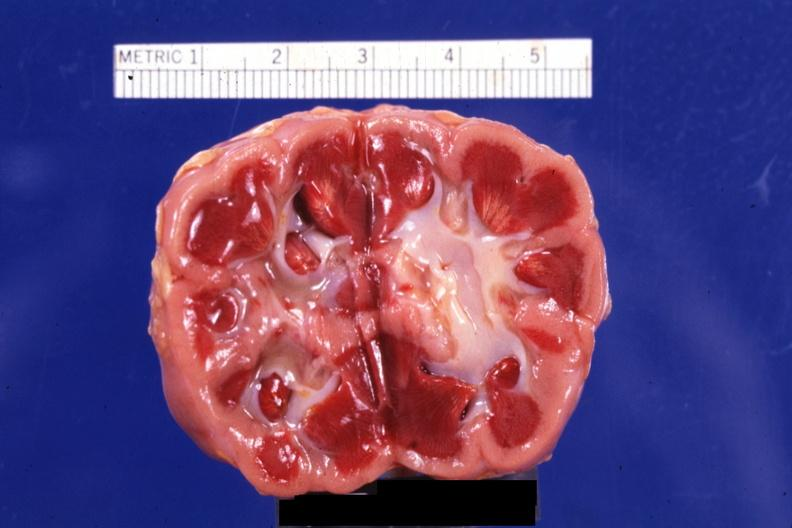s ischemia present?
Answer the question using a single word or phrase. Yes 